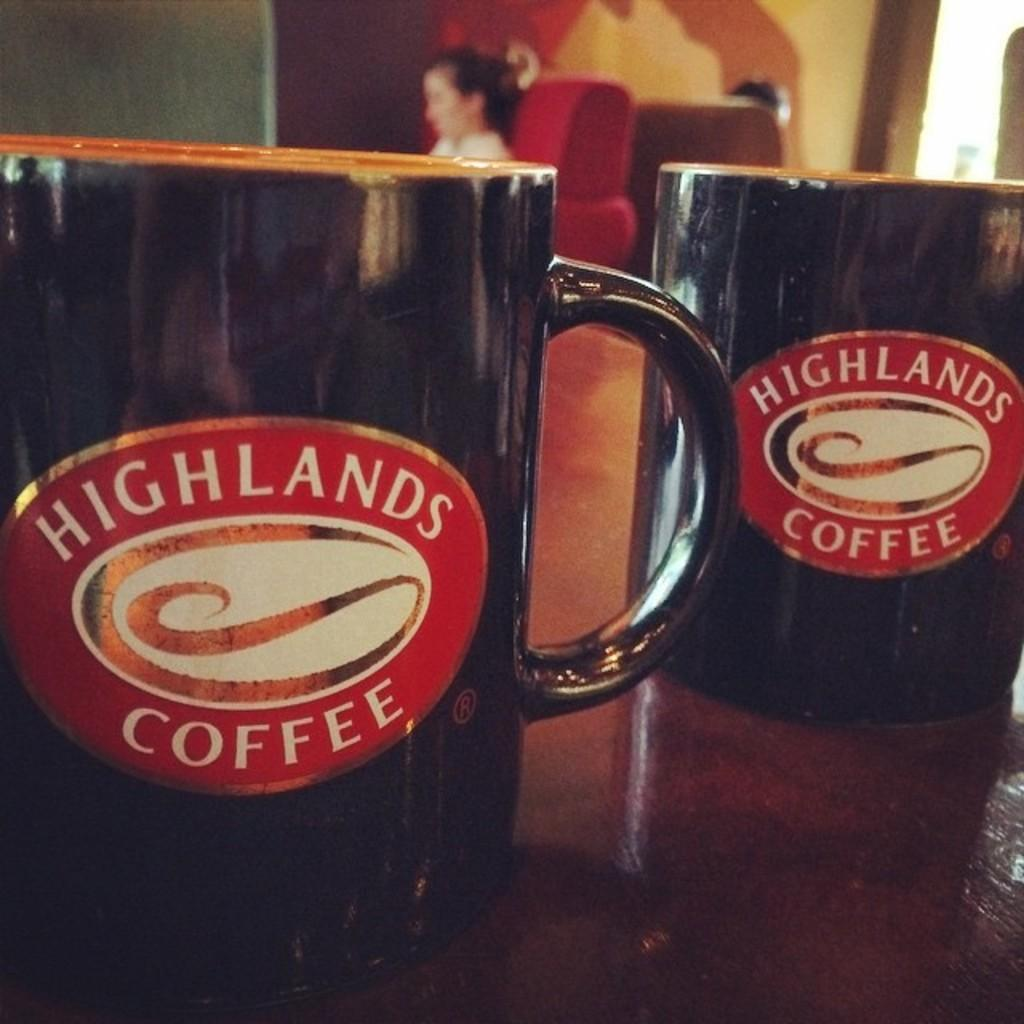<image>
Render a clear and concise summary of the photo. a cup that says Highlands Coffee on uit 